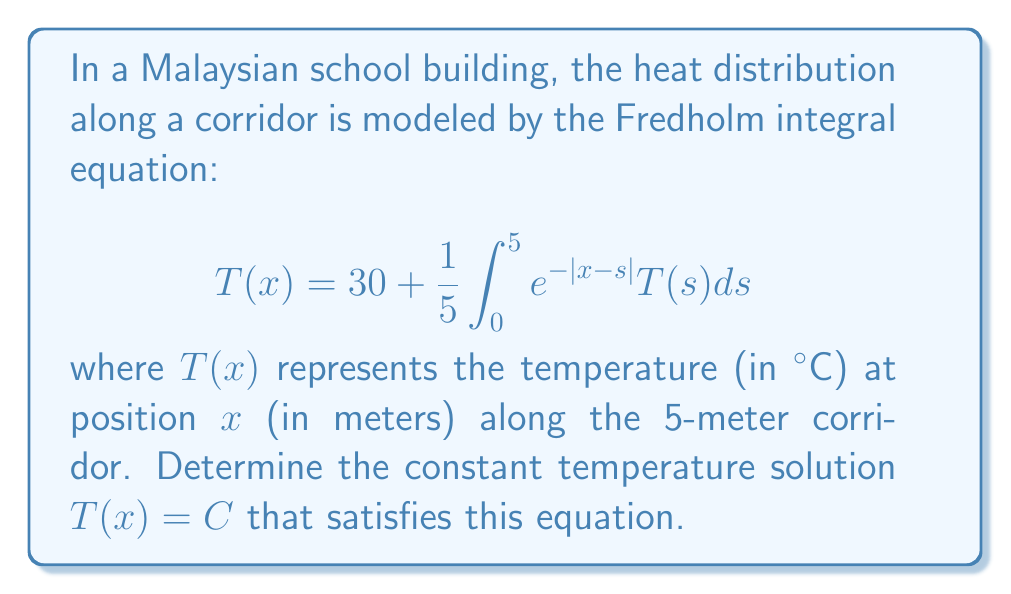Teach me how to tackle this problem. Let's solve this step-by-step:

1) Since we're looking for a constant solution, we assume $T(x) = C$ for all $x$.

2) Substituting this into the equation:

   $$C = 30 + \frac{1}{5}\int_0^5 e^{-|x-s|}C ds$$

3) The constant $C$ can be factored out of the integral:

   $$C = 30 + \frac{C}{5}\int_0^5 e^{-|x-s|} ds$$

4) The integral $\int_0^5 e^{-|x-s|} ds$ is independent of $x$ and equals 2 for any $x$ in $[0,5]$. To see this:

   For $x \leq s$: $\int_x^5 e^{-(s-x)} ds = [-e^{-(s-x)}]_x^5 = 1 - e^{-(5-x)}$
   For $x > s$: $\int_0^x e^{-(x-s)} ds = [e^{-(x-s)}]_0^x = 1 - e^{-x}$

   The sum of these is always 2.

5) Substituting this result:

   $$C = 30 + \frac{2C}{5}$$

6) Solving for $C$:

   $$C - \frac{2C}{5} = 30$$
   $$\frac{5C}{5} - \frac{2C}{5} = 30$$
   $$\frac{3C}{5} = 30$$
   $$C = 50$$

Therefore, the constant temperature solution is $T(x) = 50°C$.
Answer: $T(x) = 50°C$ 